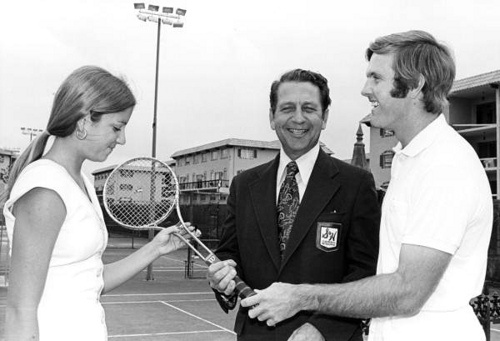Describe the objects in this image and their specific colors. I can see people in white, darkgray, gray, and black tones, people in white, black, gray, darkgray, and lightgray tones, people in white, darkgray, gray, and black tones, tennis racket in white, darkgray, gray, lightgray, and black tones, and tie in white, gray, black, and lightgray tones in this image. 